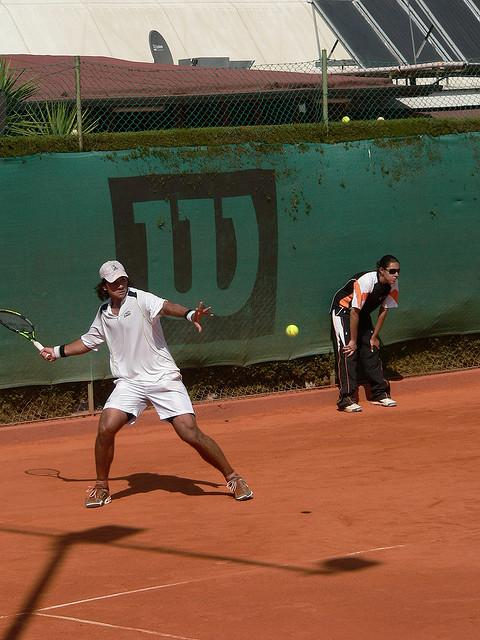What company is sponsoring the tennis match? wilson 